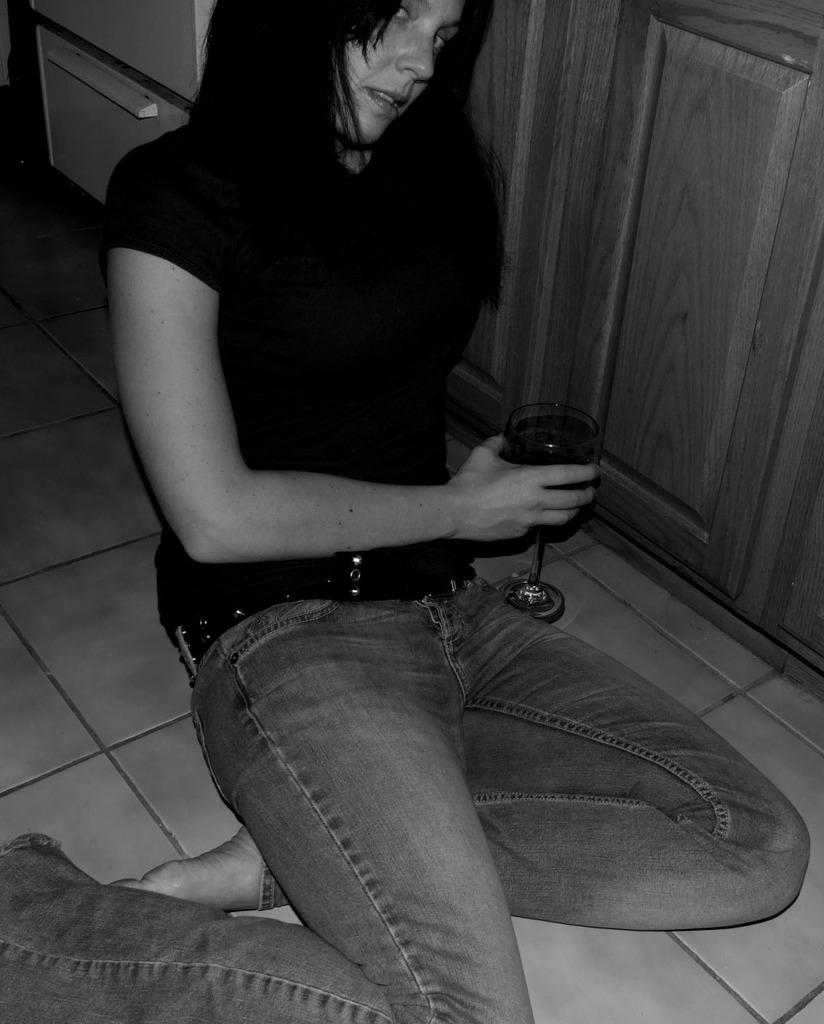What is the main subject of the image? The main subject of the image is a woman. What is the woman doing in the image? The woman is sitting on the floor in the image. What object is the woman holding in the image? The woman is holding a glass in the image. What type of paste is the woman using to show her artwork in the image? There is no paste or artwork present in the image; the woman is simply sitting on the floor holding a glass. 